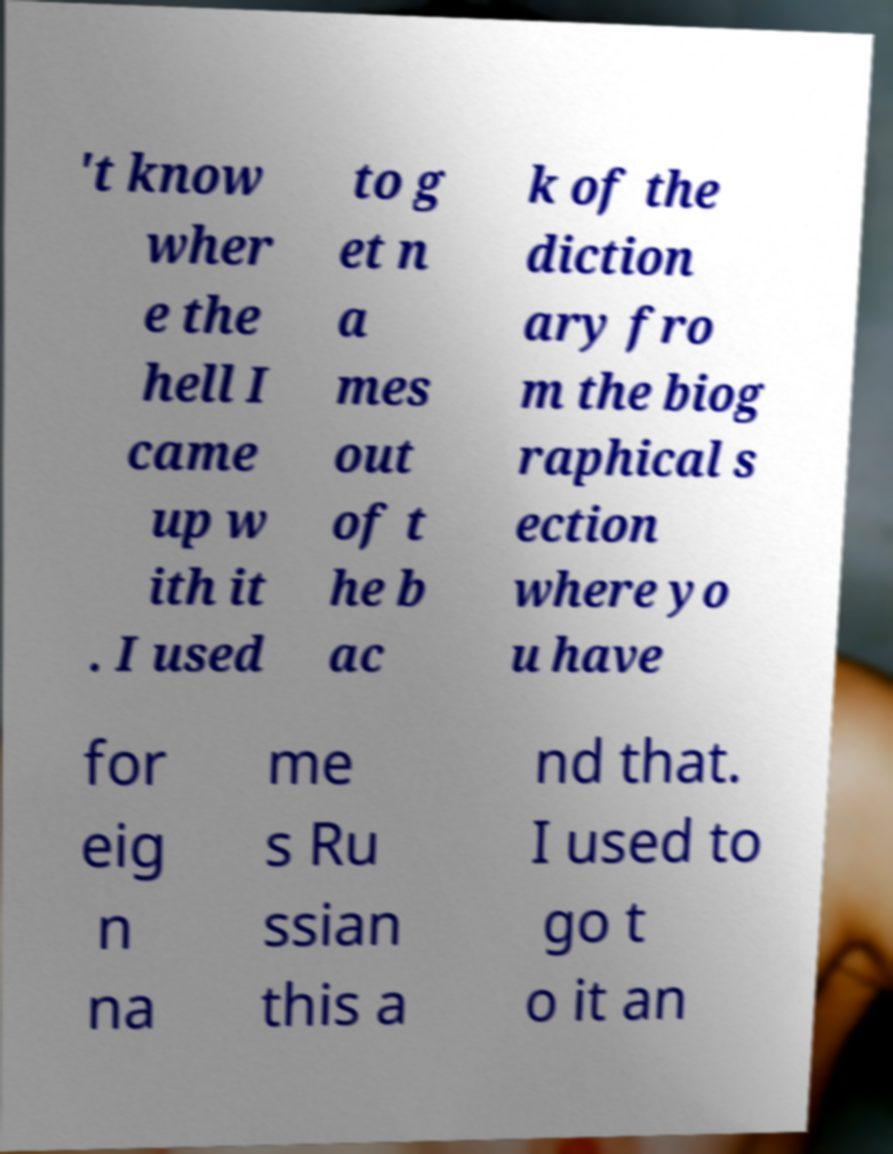I need the written content from this picture converted into text. Can you do that? 't know wher e the hell I came up w ith it . I used to g et n a mes out of t he b ac k of the diction ary fro m the biog raphical s ection where yo u have for eig n na me s Ru ssian this a nd that. I used to go t o it an 